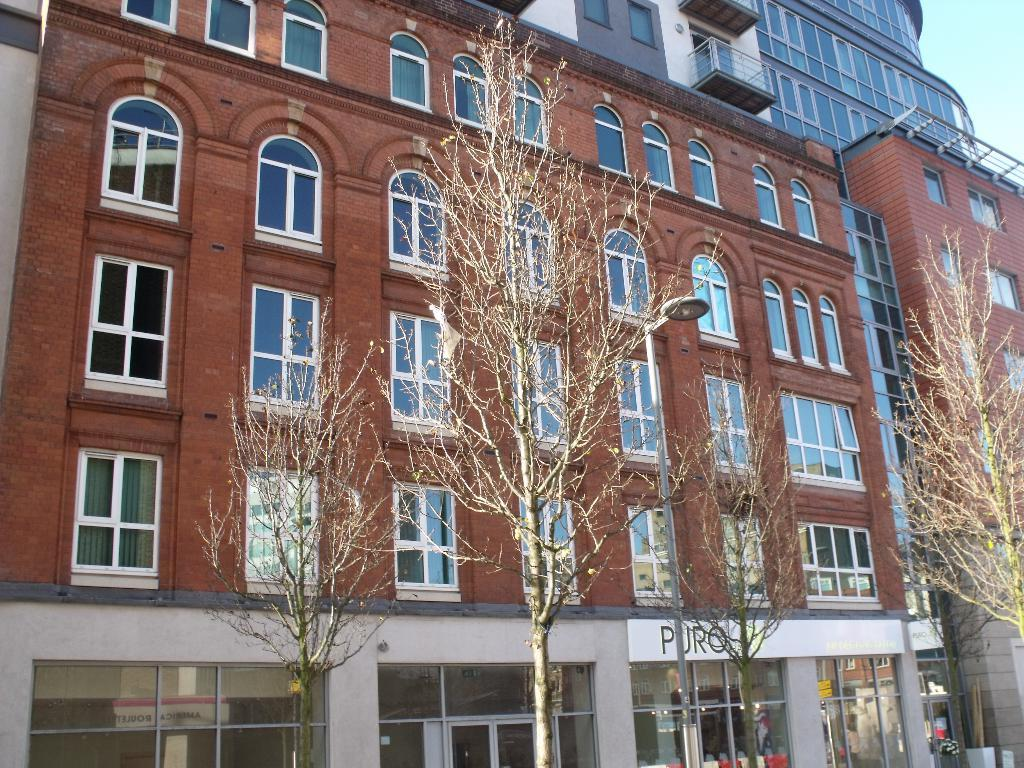What is located in the center of the image? There are buildings in the center of the image. What type of vegetation is in front of the buildings? There are trees in front of the buildings. What type of arch can be seen in the image? There is no arch present in the image; it features buildings and trees. How does the chin of the person in the image look like? There is no person present in the image, so it's not possible to determine the appearance of their chin. 